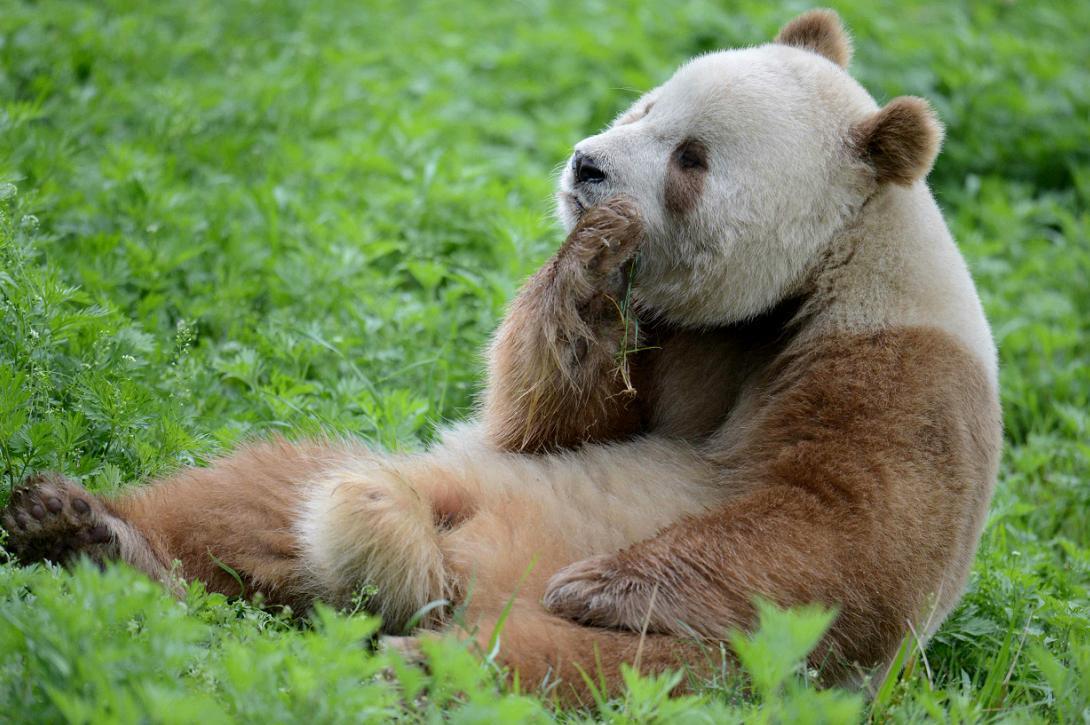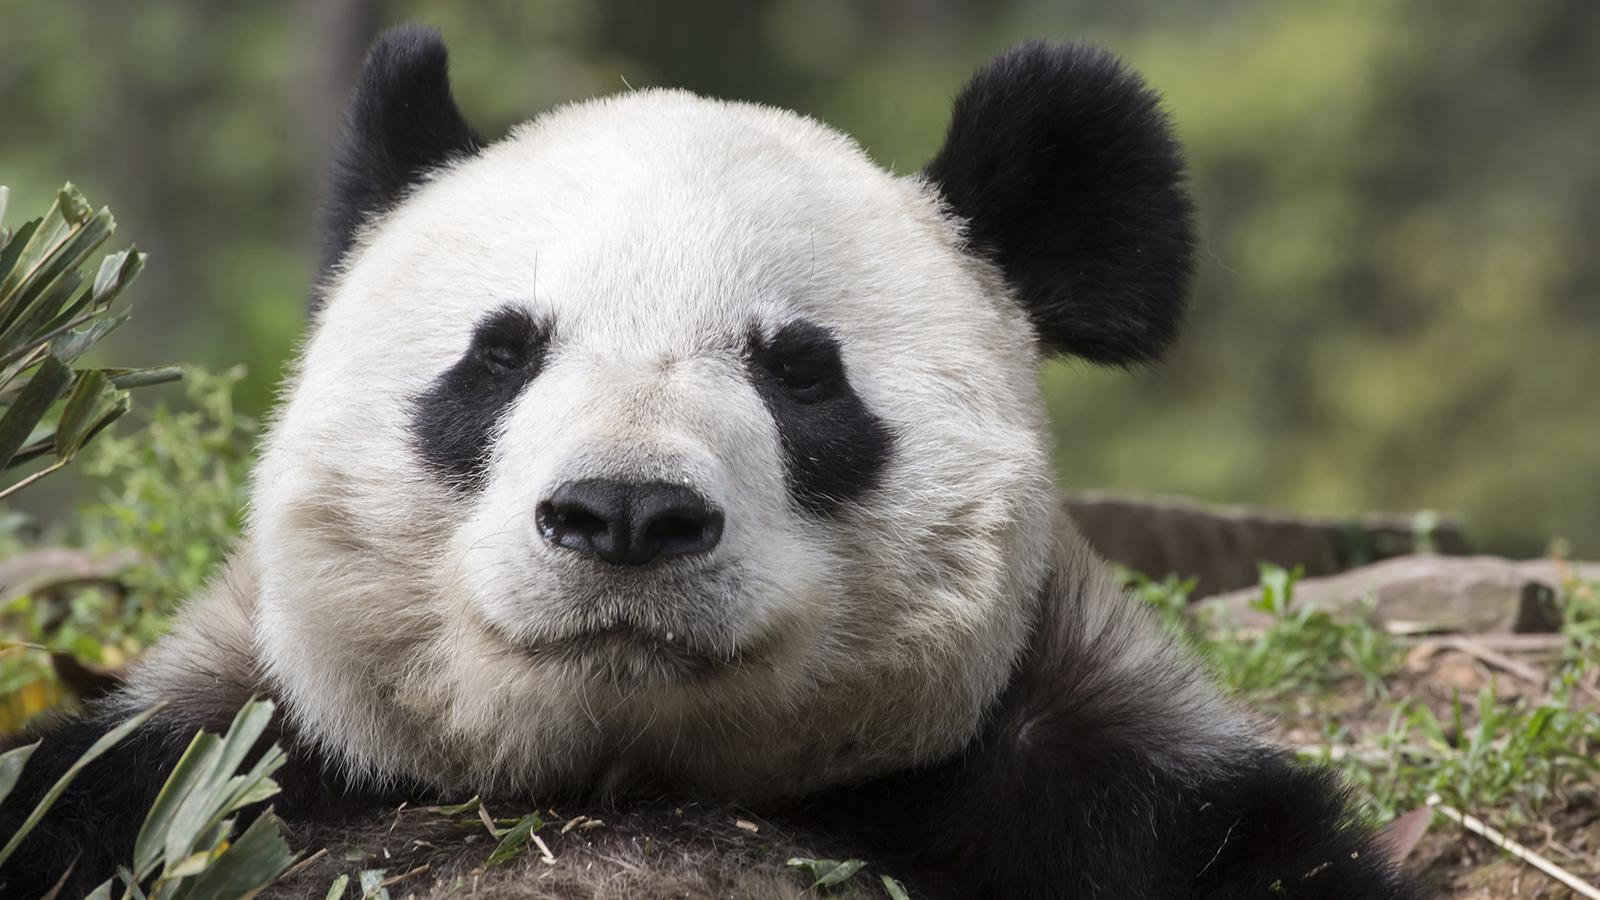The first image is the image on the left, the second image is the image on the right. Assess this claim about the two images: "A panda is resting its chin.". Correct or not? Answer yes or no. Yes. The first image is the image on the left, the second image is the image on the right. For the images shown, is this caption "An image includes a panda at least partly on its back on green ground." true? Answer yes or no. Yes. 